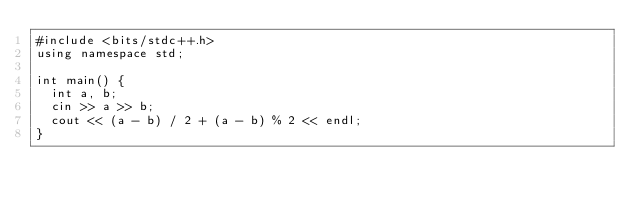<code> <loc_0><loc_0><loc_500><loc_500><_C++_>#include <bits/stdc++.h>
using namespace std;

int main() {
  int a, b;
  cin >> a >> b;
  cout << (a - b) / 2 + (a - b) % 2 << endl;
}
</code> 